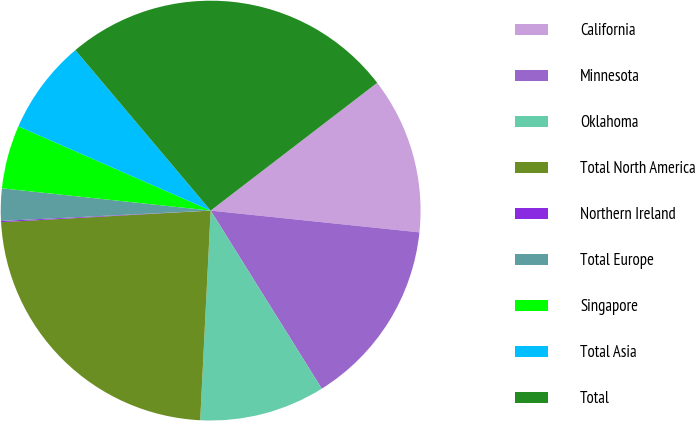<chart> <loc_0><loc_0><loc_500><loc_500><pie_chart><fcel>California<fcel>Minnesota<fcel>Oklahoma<fcel>Total North America<fcel>Northern Ireland<fcel>Total Europe<fcel>Singapore<fcel>Total Asia<fcel>Total<nl><fcel>12.07%<fcel>14.47%<fcel>9.67%<fcel>23.33%<fcel>0.09%<fcel>2.48%<fcel>4.88%<fcel>7.28%<fcel>25.73%<nl></chart> 